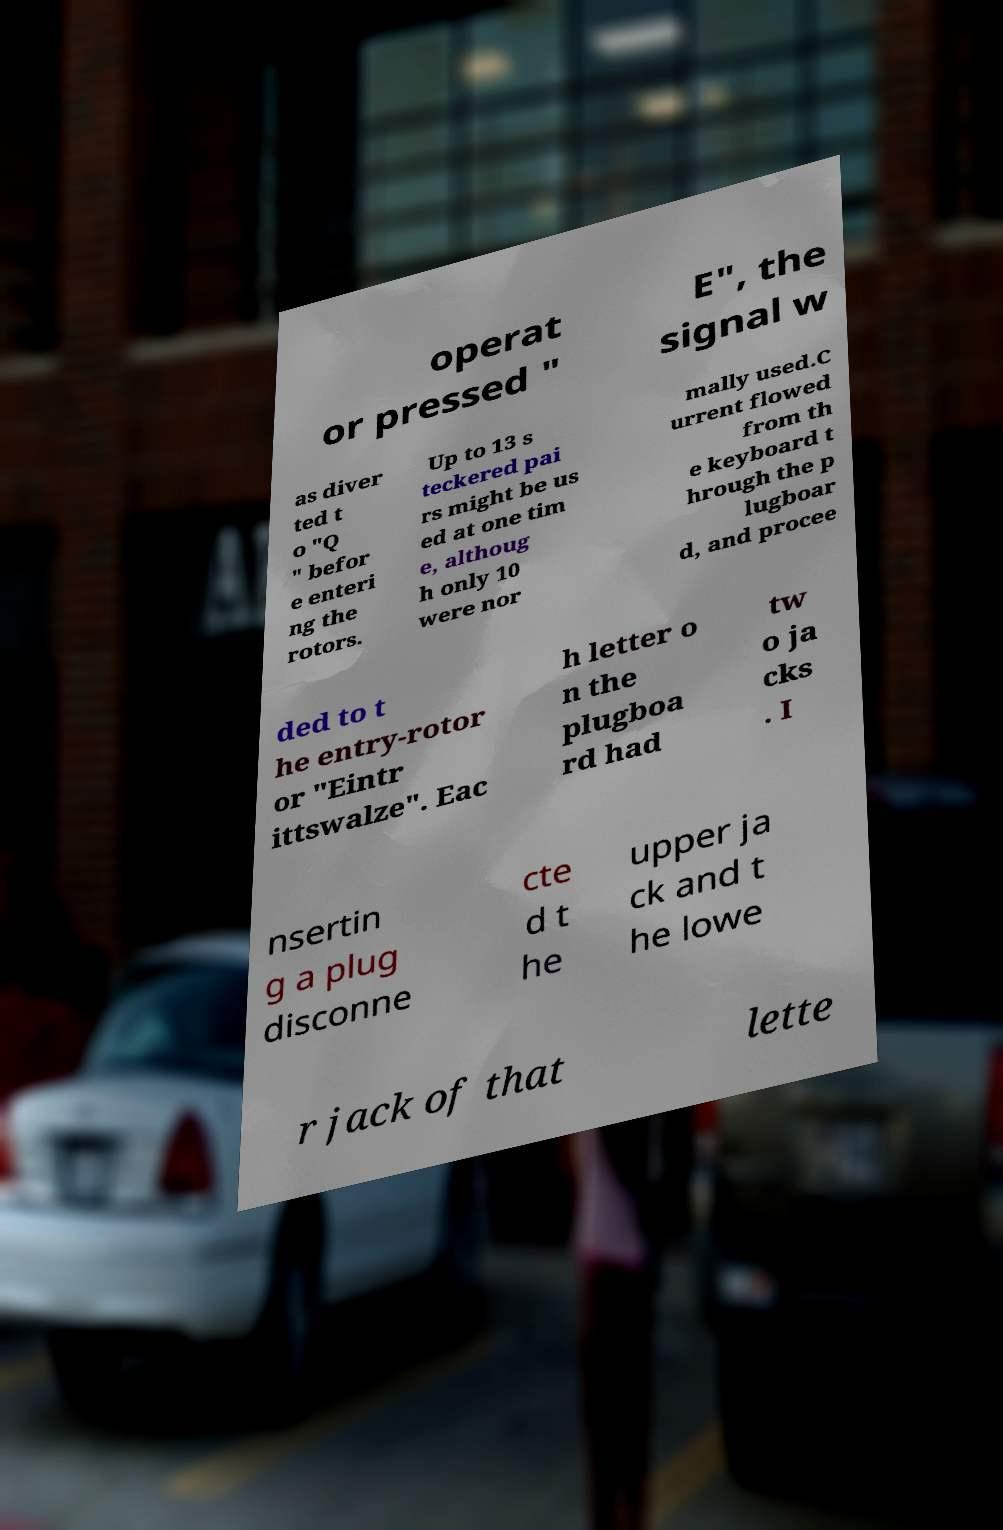I need the written content from this picture converted into text. Can you do that? operat or pressed " E", the signal w as diver ted t o "Q " befor e enteri ng the rotors. Up to 13 s teckered pai rs might be us ed at one tim e, althoug h only 10 were nor mally used.C urrent flowed from th e keyboard t hrough the p lugboar d, and procee ded to t he entry-rotor or "Eintr ittswalze". Eac h letter o n the plugboa rd had tw o ja cks . I nsertin g a plug disconne cte d t he upper ja ck and t he lowe r jack of that lette 